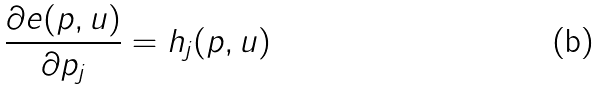Convert formula to latex. <formula><loc_0><loc_0><loc_500><loc_500>\frac { \partial e ( p , u ) } { \partial p _ { j } } = h _ { j } ( p , u )</formula> 